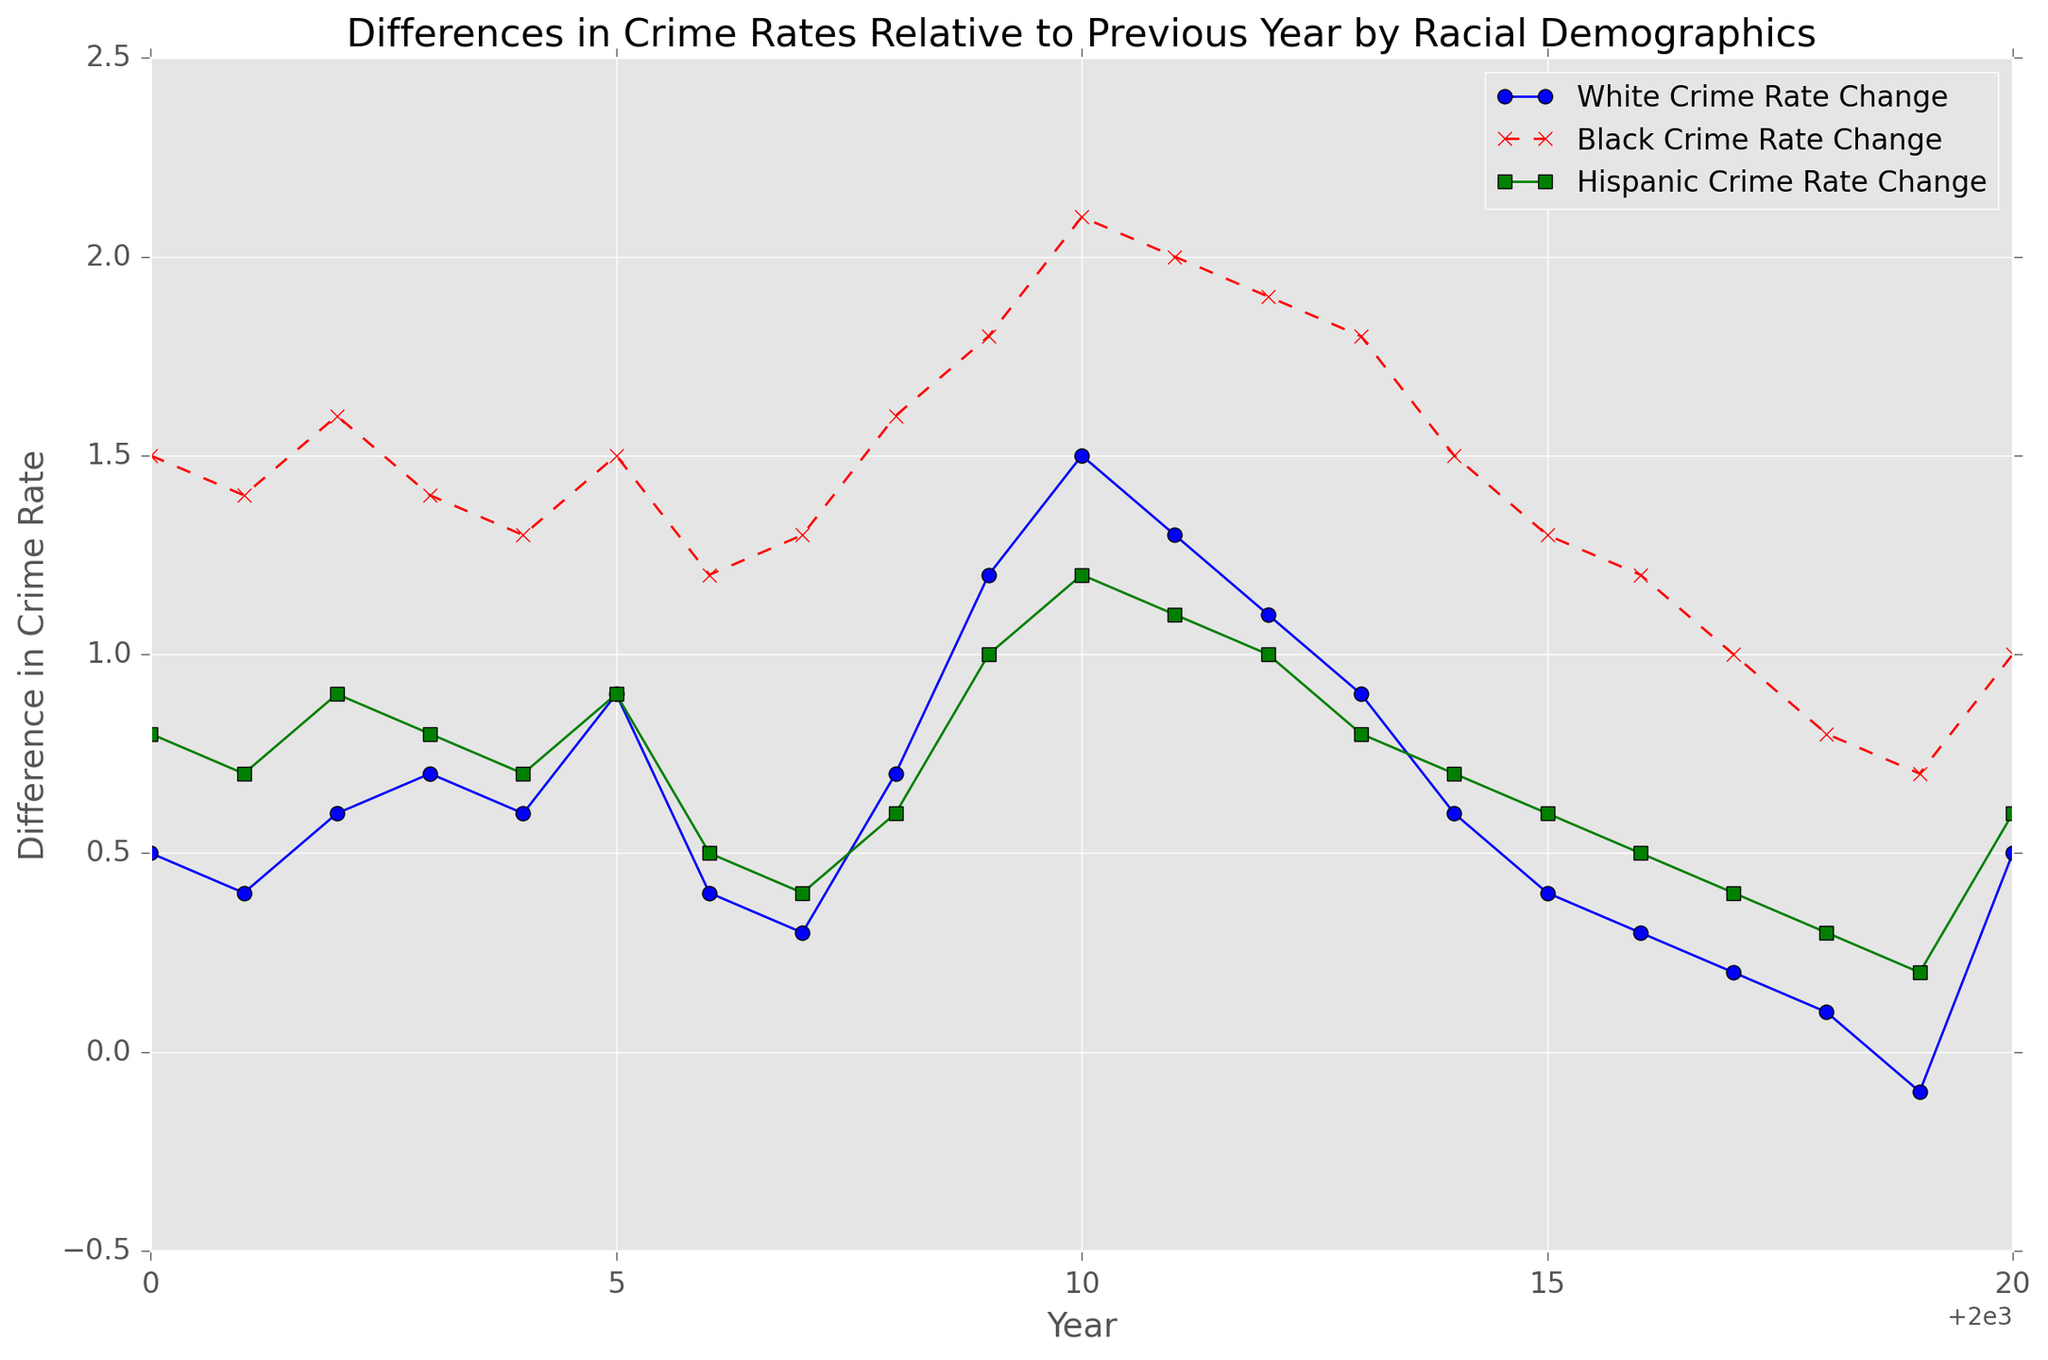What's the trend in the crime rate change for the White demographic over the years? To determine the trend, observe the "White Crime Rate Change" line on the plot. Initially, it fluctuated slightly between 0.2 and 1.5 percent from 2000 to 2010, then began to consistently decrease, reaching around -0.1 percent by 2019. In 2020, it increased slightly to 0.5 percent.
Answer: Overall decreasing trend In which year did the Black demographic have the highest crime rate change? Observe the "Black Crime Rate Change" line and look for the peak value. The highest crime rate change for the Black demographic was around 2.1 percent in 2010.
Answer: 2010 How do the crime rate changes compare between the Black and Hispanic demographics in 2010? To compare, find the values for both demographics in 2010. The Black crime rate change is about 2.1 percent, while the Hispanic crime rate change is roughly 1.2 percent.
Answer: Black's change is higher In which years did the White demographic experience a negative crime rate change? Identify when the "White Crime Rate Change" line dips below zero. The negative change occurred in 2019.
Answer: 2019 What is the minimum crime rate change for the Hispanic demographic shown in the plot? Identify the lowest point on the "Hispanic Crime Rate Change" line. The crime rate change reaches a minimum of about 0.2 percent in 2019.
Answer: 0.2 percent Which demographic shows the most significant variation in crime rate changes? Compare the vertical spread of the lines representing each demographic. The Black demographic shows the most significant variation, ranging from about 0.7 percent to 2.1 percent.
Answer: Black What is the crime rate change for the White demographic in 2005, and how does it compare to 2015? Observe the values for 2005 and 2015 on the "White Crime Rate Change" line. In 2005, the change is about 0.9 percent; in 2015, it is approximately 0.4 percent.
Answer: 0.5 percent decrease During which years did all three demographics show a simultaneous increase in crime rate change? Look for instances where all lines show an upward trend within the same years. Between 2009 and 2010, all three demographic lines are rising.
Answer: 2009-2010 In which years did the Hispanic demographic have a crime rate change between 0.5 and 1.0 percent? Identify periods when the "Hispanic Crime Rate Change" line is between 0.5 and 1.0 percent. This happens in 2000, 2002, 2005, 2008, 2009, 2010, 2011, and 2012.
Answer: 2000, 2002, 2005, 2008, 2009, 2010, 2011, 2012 